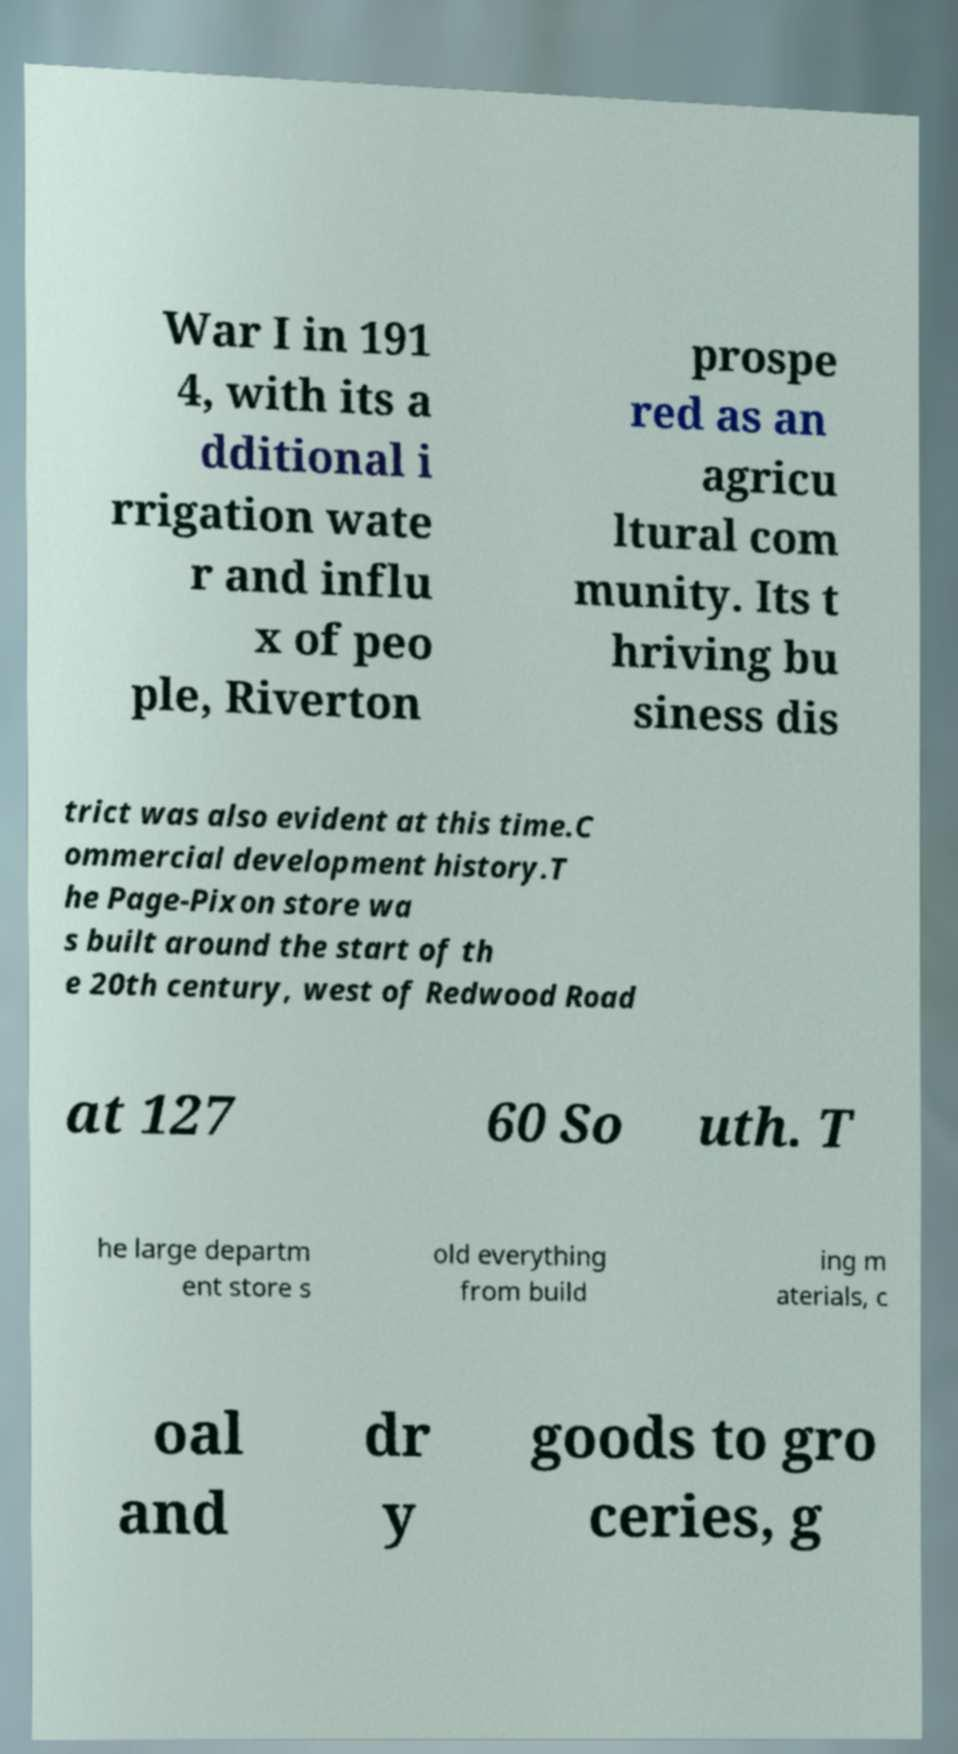There's text embedded in this image that I need extracted. Can you transcribe it verbatim? War I in 191 4, with its a dditional i rrigation wate r and influ x of peo ple, Riverton prospe red as an agricu ltural com munity. Its t hriving bu siness dis trict was also evident at this time.C ommercial development history.T he Page-Pixon store wa s built around the start of th e 20th century, west of Redwood Road at 127 60 So uth. T he large departm ent store s old everything from build ing m aterials, c oal and dr y goods to gro ceries, g 